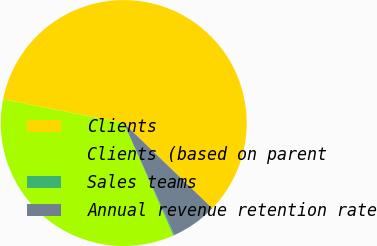<chart> <loc_0><loc_0><loc_500><loc_500><pie_chart><fcel>Clients<fcel>Clients (based on parent<fcel>Sales teams<fcel>Annual revenue retention rate<nl><fcel>59.11%<fcel>34.72%<fcel>0.14%<fcel>6.04%<nl></chart> 